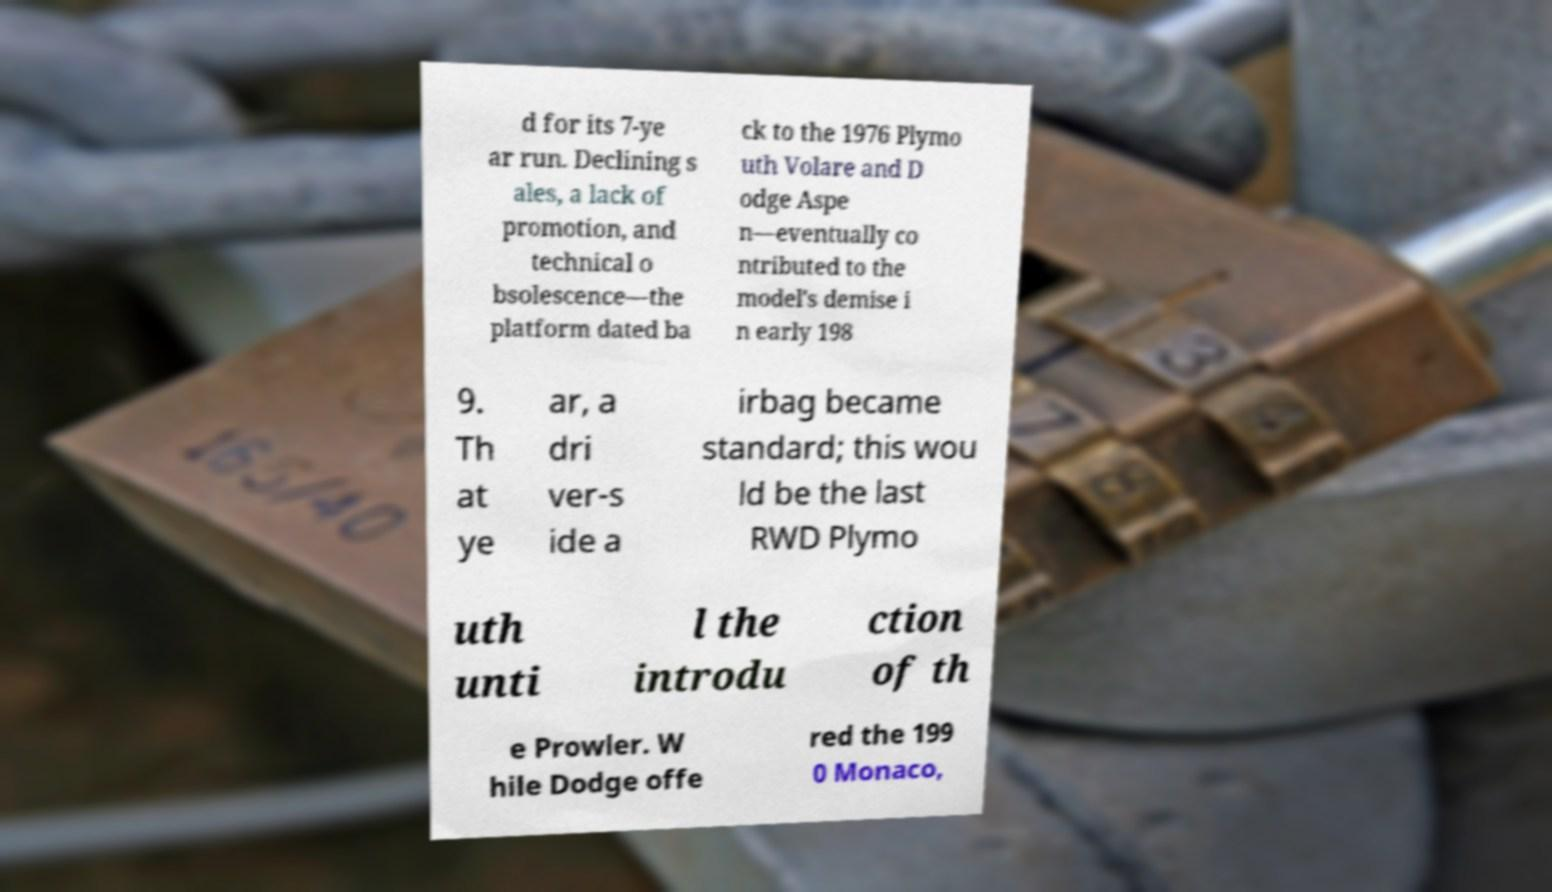What messages or text are displayed in this image? I need them in a readable, typed format. d for its 7-ye ar run. Declining s ales, a lack of promotion, and technical o bsolescence—the platform dated ba ck to the 1976 Plymo uth Volare and D odge Aspe n—eventually co ntributed to the model's demise i n early 198 9. Th at ye ar, a dri ver-s ide a irbag became standard; this wou ld be the last RWD Plymo uth unti l the introdu ction of th e Prowler. W hile Dodge offe red the 199 0 Monaco, 